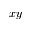<formula> <loc_0><loc_0><loc_500><loc_500>x y</formula> 